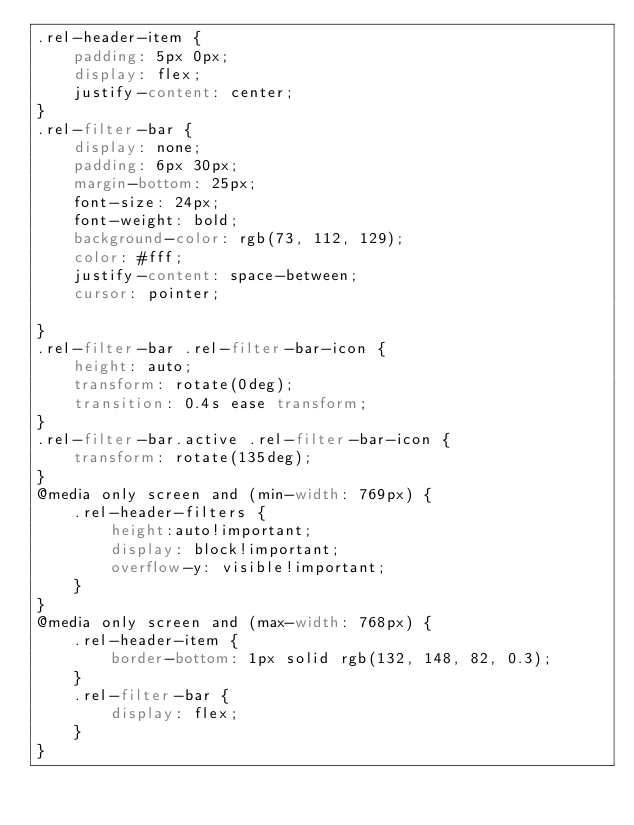<code> <loc_0><loc_0><loc_500><loc_500><_CSS_>.rel-header-item {
    padding: 5px 0px;
    display: flex;
    justify-content: center;
}
.rel-filter-bar {
    display: none;
    padding: 6px 30px;
    margin-bottom: 25px;
    font-size: 24px;
    font-weight: bold;
    background-color: rgb(73, 112, 129);
    color: #fff;
    justify-content: space-between;
    cursor: pointer;
    
}
.rel-filter-bar .rel-filter-bar-icon {
    height: auto;
    transform: rotate(0deg);
    transition: 0.4s ease transform;
}
.rel-filter-bar.active .rel-filter-bar-icon {
    transform: rotate(135deg);
}
@media only screen and (min-width: 769px) {
    .rel-header-filters {
        height:auto!important;
        display: block!important;
        overflow-y: visible!important;
    }
}
@media only screen and (max-width: 768px) {
    .rel-header-item {
        border-bottom: 1px solid rgb(132, 148, 82, 0.3);
    }
    .rel-filter-bar {
        display: flex;
    }
}</code> 